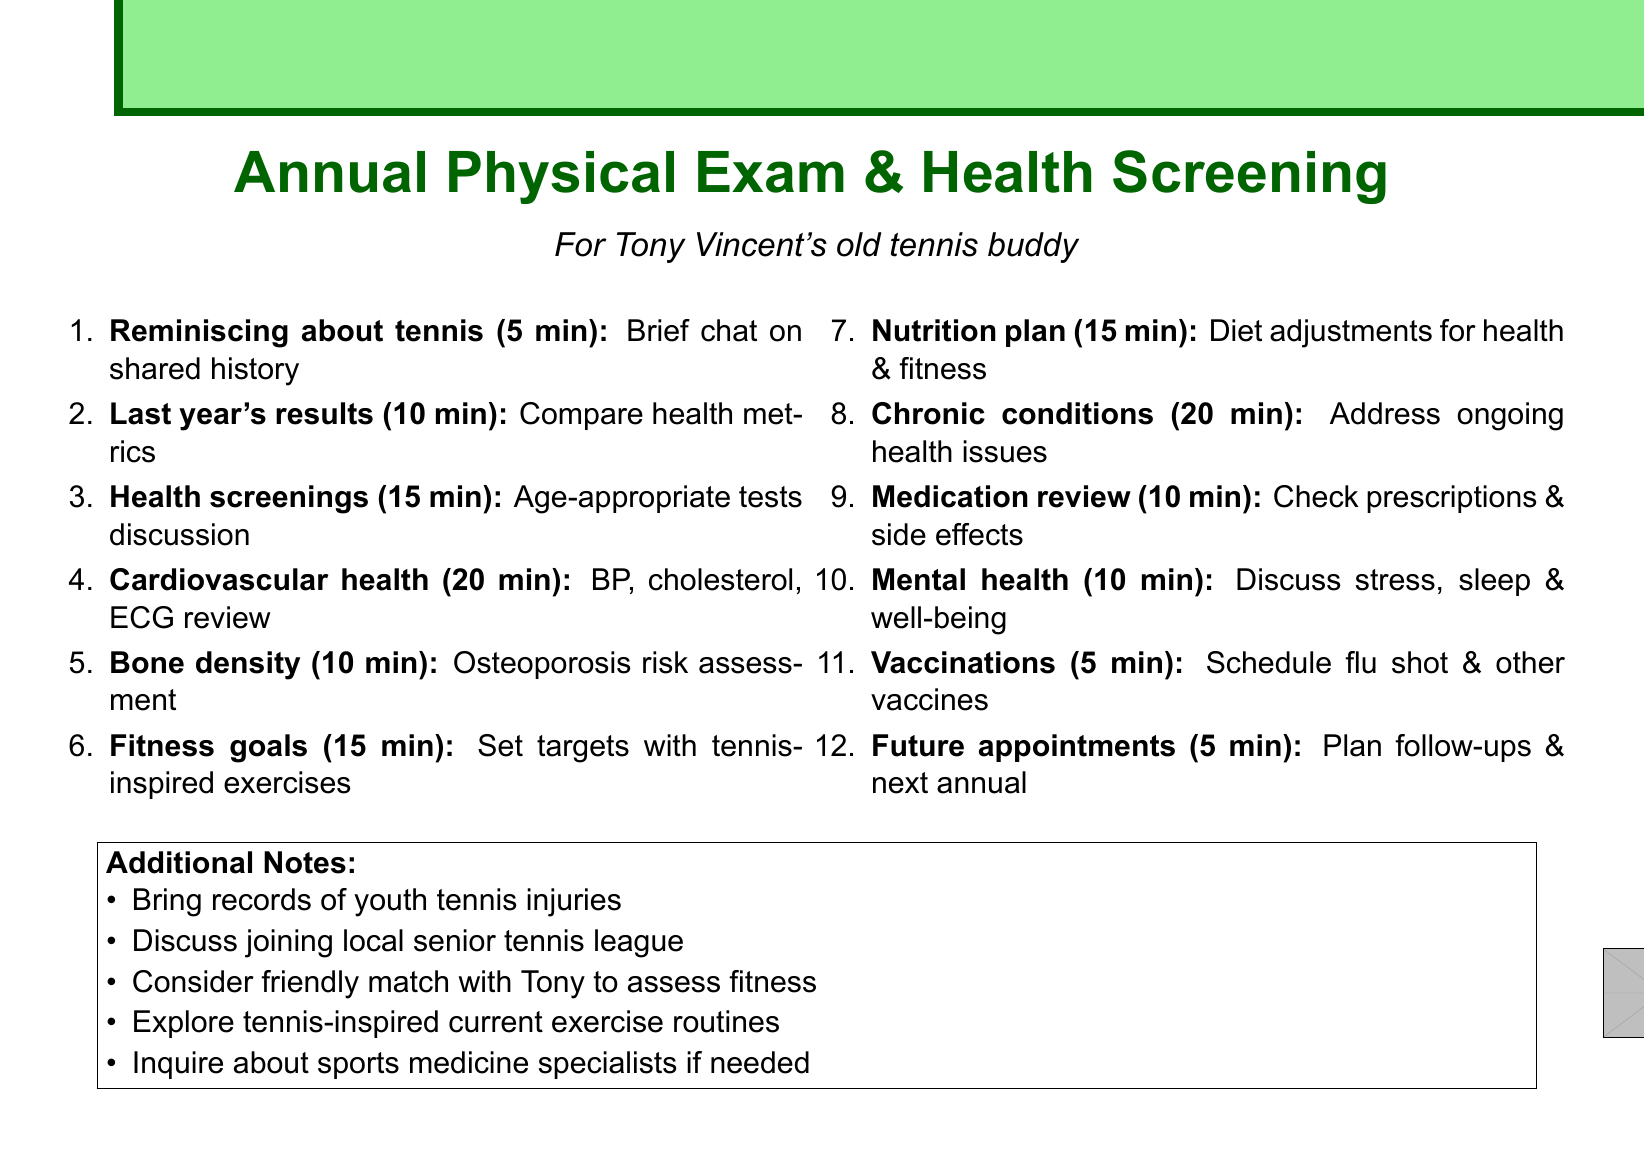What is the title of the agenda? The title of the agenda is mentioned at the beginning, stating the purpose of the document for Tony Vincent's old tennis buddy.
Answer: Annual Physical Exam & Health Screening How long is the discussion on cardiovascular health assessment? This question requires retrieving the duration specified for that agenda item.
Answer: 20 minutes What topic is covered in the first agenda item? The first agenda item is specifically about reminiscing about shared history.
Answer: Reminiscing about tennis days with Tony Vincent How many minutes are allocated for the nutrition plan review? The duration for this specific agenda item is clearly listed in the document.
Answer: 15 minutes Which health screenings are discussed as being age-appropriate? This requires understanding that the agenda discusses specific tests related to health based on age.
Answer: colonoscopy and prostate exam What does the agenda highlight regarding the fitness goals? This asks about the content of the fitness goals item, requiring synthesis of information.
Answer: Setting realistic targets for maintaining flexibility and strength How many agenda items discuss chronic condition management? This involves counting specific items that fall into the category of chronic conditions.
Answer: 1 When should vaccinations be reviewed in the agenda? This requires locating the specific agenda item related to vaccinations.
Answer: 5 minutes What is the total duration of the document's agenda items? This requires summing the individual durations of all items to find the total time allocated.
Answer: Total 2 hours 30 minutes 